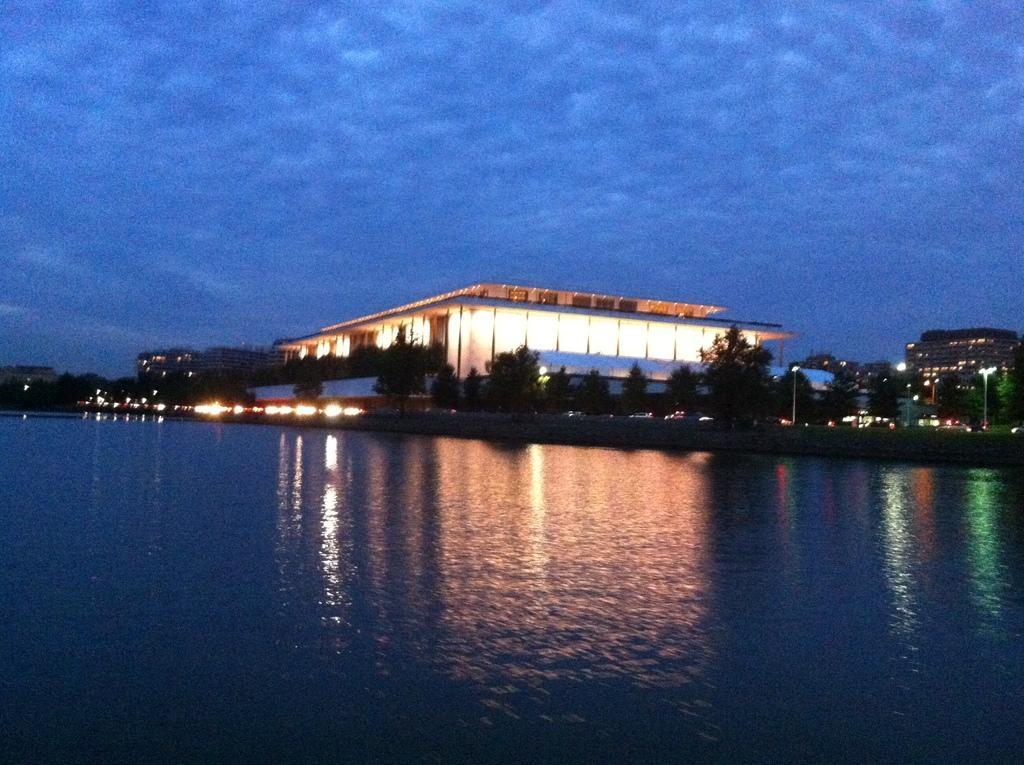In one or two sentences, can you explain what this image depicts? In this image I can see trees, lights and buildings. In the background I can see the water and the sky. 